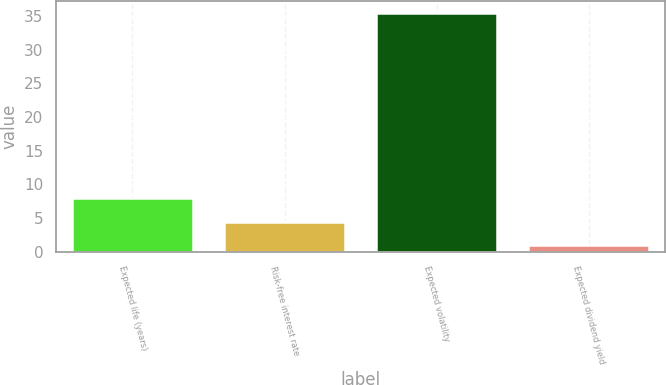Convert chart. <chart><loc_0><loc_0><loc_500><loc_500><bar_chart><fcel>Expected life (years)<fcel>Risk-free interest rate<fcel>Expected volatility<fcel>Expected dividend yield<nl><fcel>7.9<fcel>4.45<fcel>35.5<fcel>1<nl></chart> 